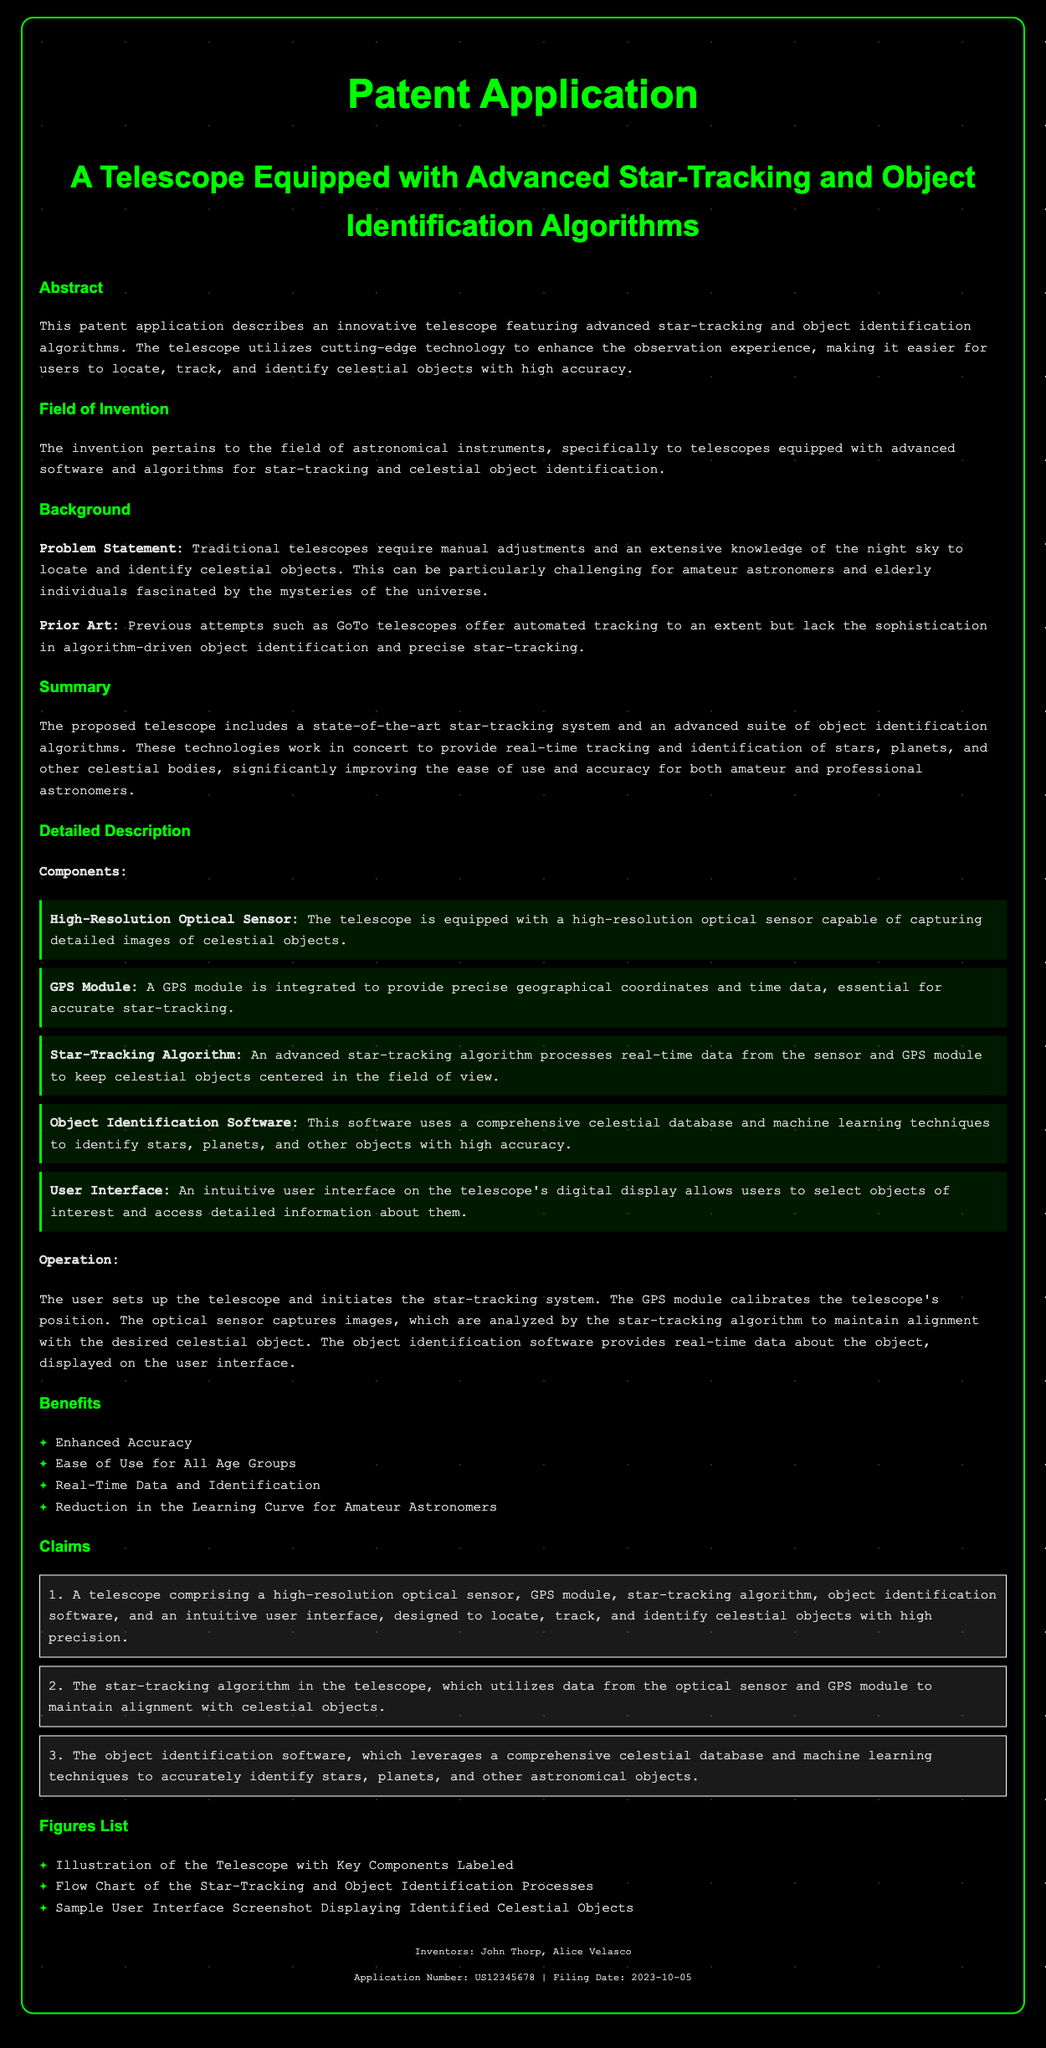What is the title of the patent application? The title is found at the beginning of the document, summarizing the invention.
Answer: A Telescope Equipped with Advanced Star-Tracking and Object Identification Algorithms Who are the inventors of the telescope? The inventors are listed in the footer section of the document.
Answer: John Thorp, Alice Velasco What is the filing date of the application? The filing date is mentioned in the footer section, indicating when the application was submitted.
Answer: 2023-10-05 What technology enhances the operation of the telescope? The abstract and summary sections describe the technology used to improve the user experience.
Answer: Advanced star-tracking and object identification algorithms What does the star-tracking algorithm utilize for maintaining alignment? The detailed description outlines the components that assist the star-tracking algorithm.
Answer: Data from the optical sensor and GPS module What benefit is mentioned regarding amateur astronomers? The benefits listed in the document indicate improvements for different user groups.
Answer: Reduction in the Learning Curve for Amateur Astronomers What kind of sensor is equipped in the telescope? The component details describe the type of sensor present in the telescope.
Answer: High-Resolution Optical Sensor How many claims are outlined in the document? The claims section enumerates the claims made for the invention.
Answer: 3 